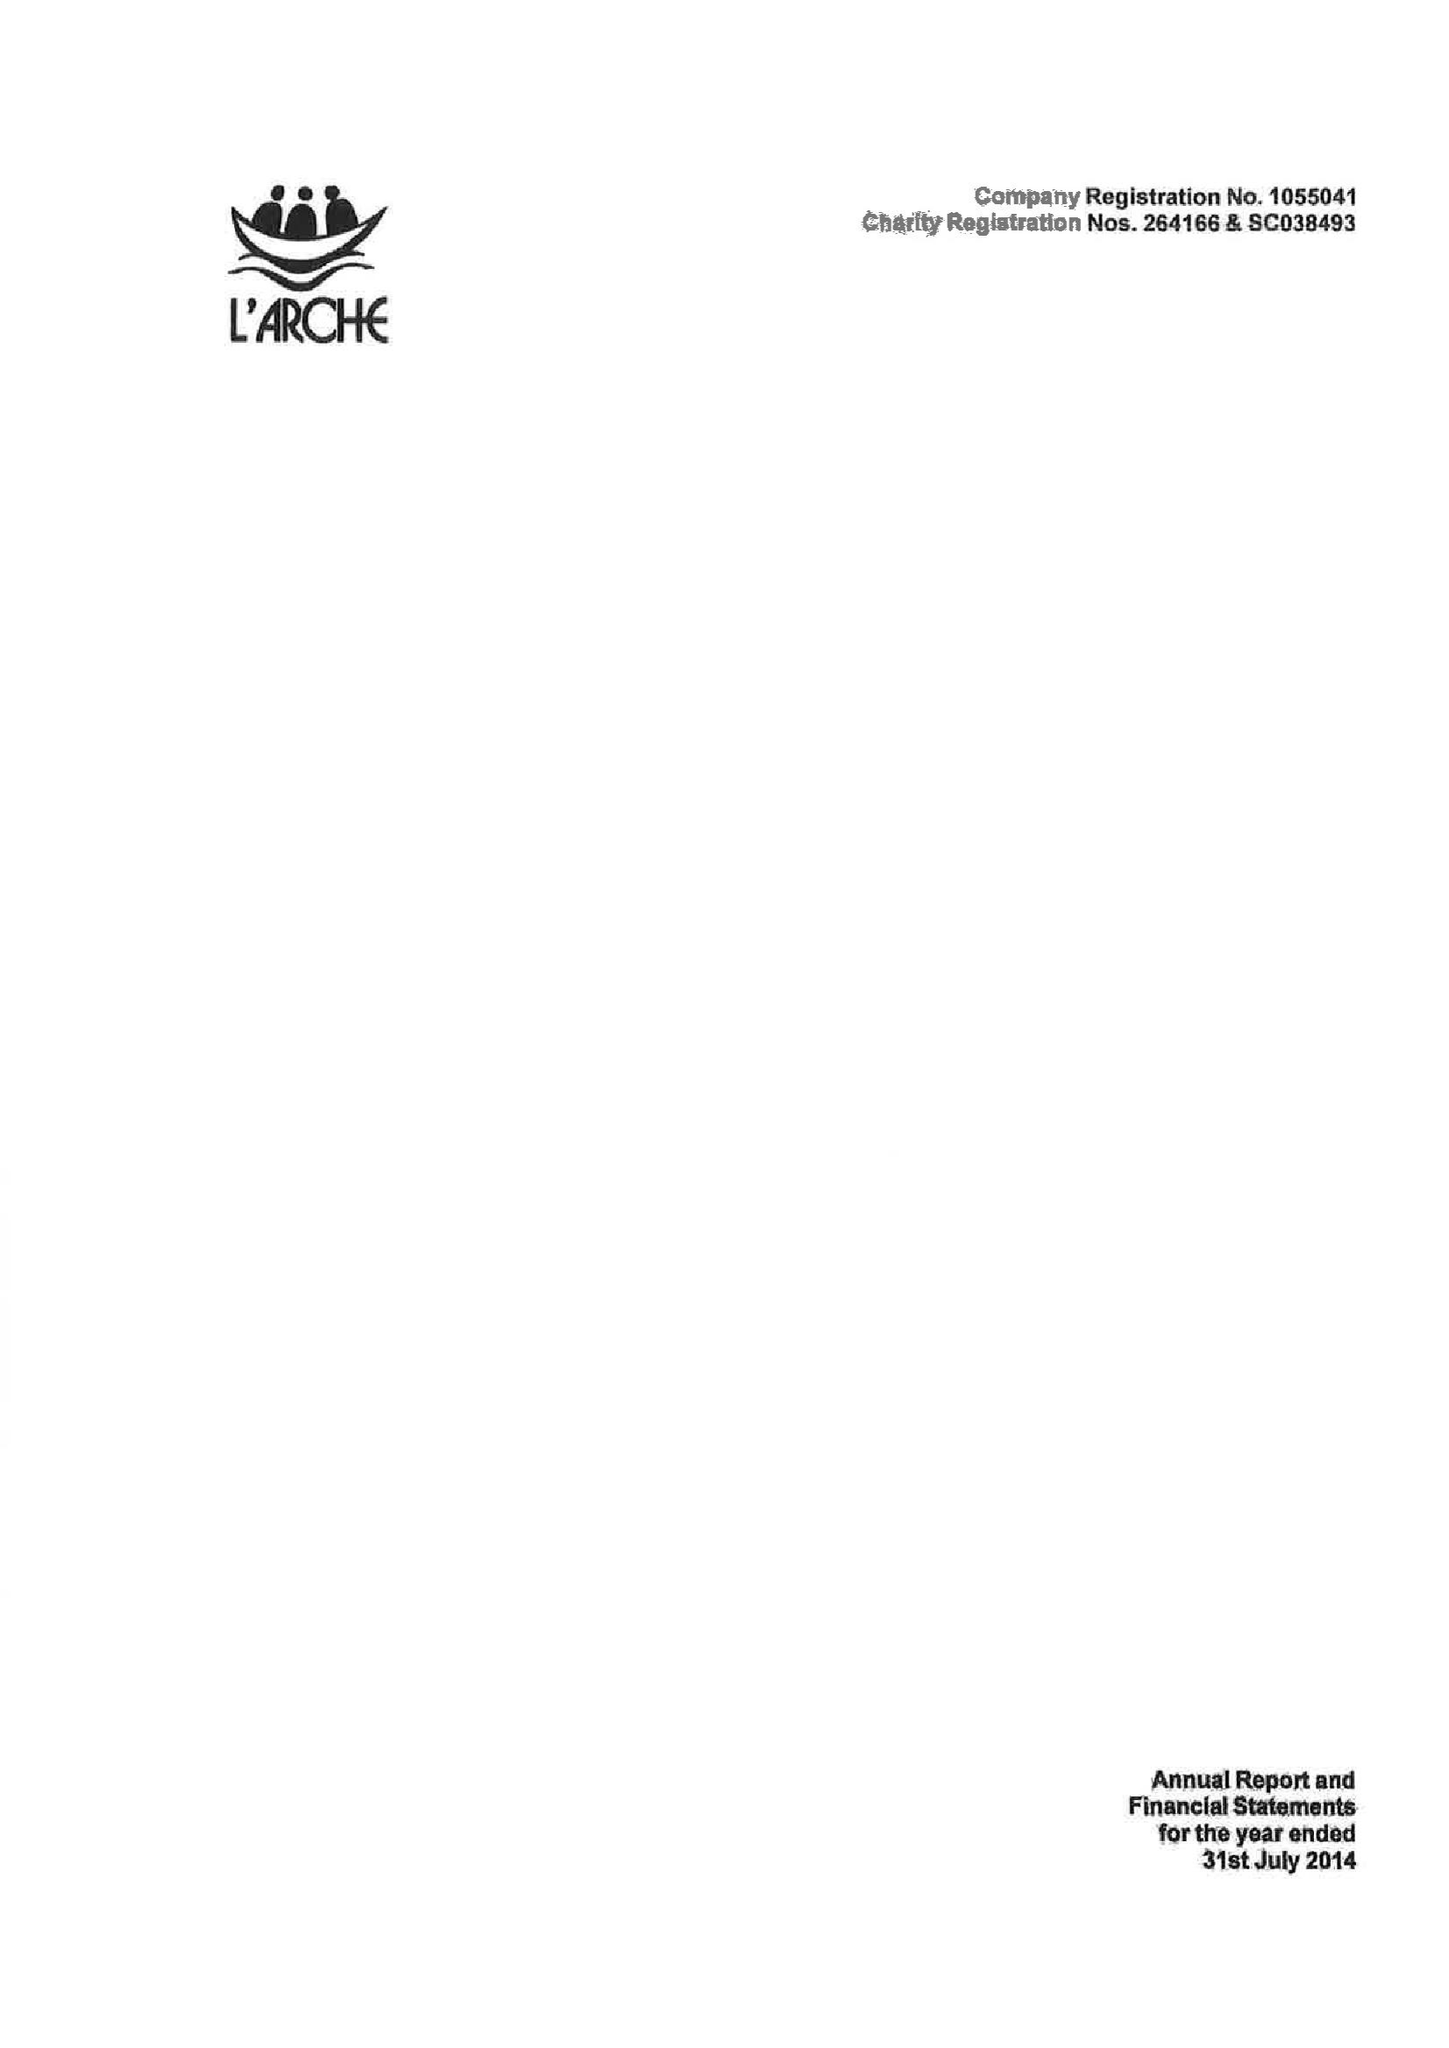What is the value for the charity_number?
Answer the question using a single word or phrase. 264166 